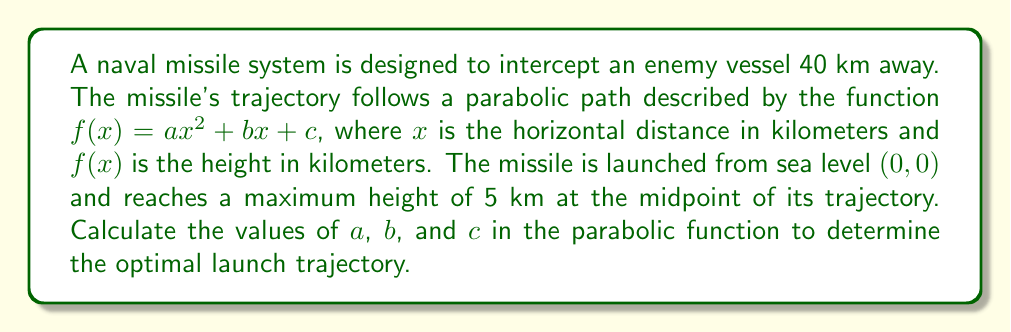Solve this math problem. Let's approach this step-by-step:

1) The parabola passes through $(0, 0)$ and $(40, 0)$, and its vertex is at $(20, 5)$.

2) Using the vertex form of a parabola: $f(x) = a(x - h)^2 + k$, where $(h, k)$ is the vertex.
   
   $f(x) = a(x - 20)^2 + 5$

3) Expanding this:
   
   $f(x) = ax^2 - 40ax + 400a + 5$

4) Comparing with the standard form $ax^2 + bx + c$:
   
   $b = -40a$
   $c = 400a + 5$

5) We know the parabola passes through $(40, 0)$. Let's use this point:

   $0 = a(40)^2 - 40a(40) + 400a + 5$
   $0 = 1600a - 1600a + 400a + 5$
   $0 = 400a + 5$
   $400a = -5$
   $a = -\frac{5}{400} = -\frac{1}{80}$

6) Now we can find $b$ and $c$:
   
   $b = -40a = -40(-\frac{1}{80}) = \frac{1}{2}$
   
   $c = 400a + 5 = 400(-\frac{1}{80}) + 5 = -5 + 5 = 0$

Therefore, the parabolic function is:

$$f(x) = -\frac{1}{80}x^2 + \frac{1}{2}x$$
Answer: $a = -\frac{1}{80}$, $b = \frac{1}{2}$, $c = 0$ 